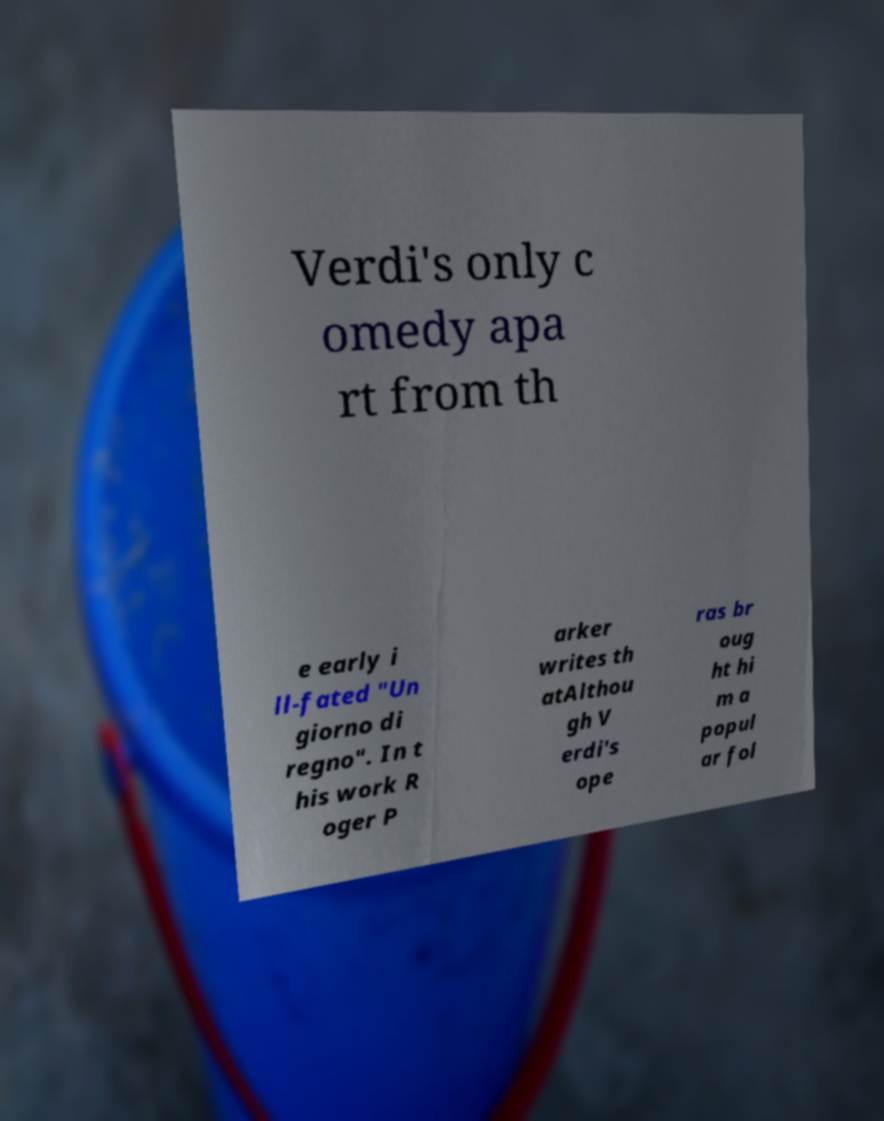What messages or text are displayed in this image? I need them in a readable, typed format. Verdi's only c omedy apa rt from th e early i ll-fated "Un giorno di regno". In t his work R oger P arker writes th atAlthou gh V erdi's ope ras br oug ht hi m a popul ar fol 